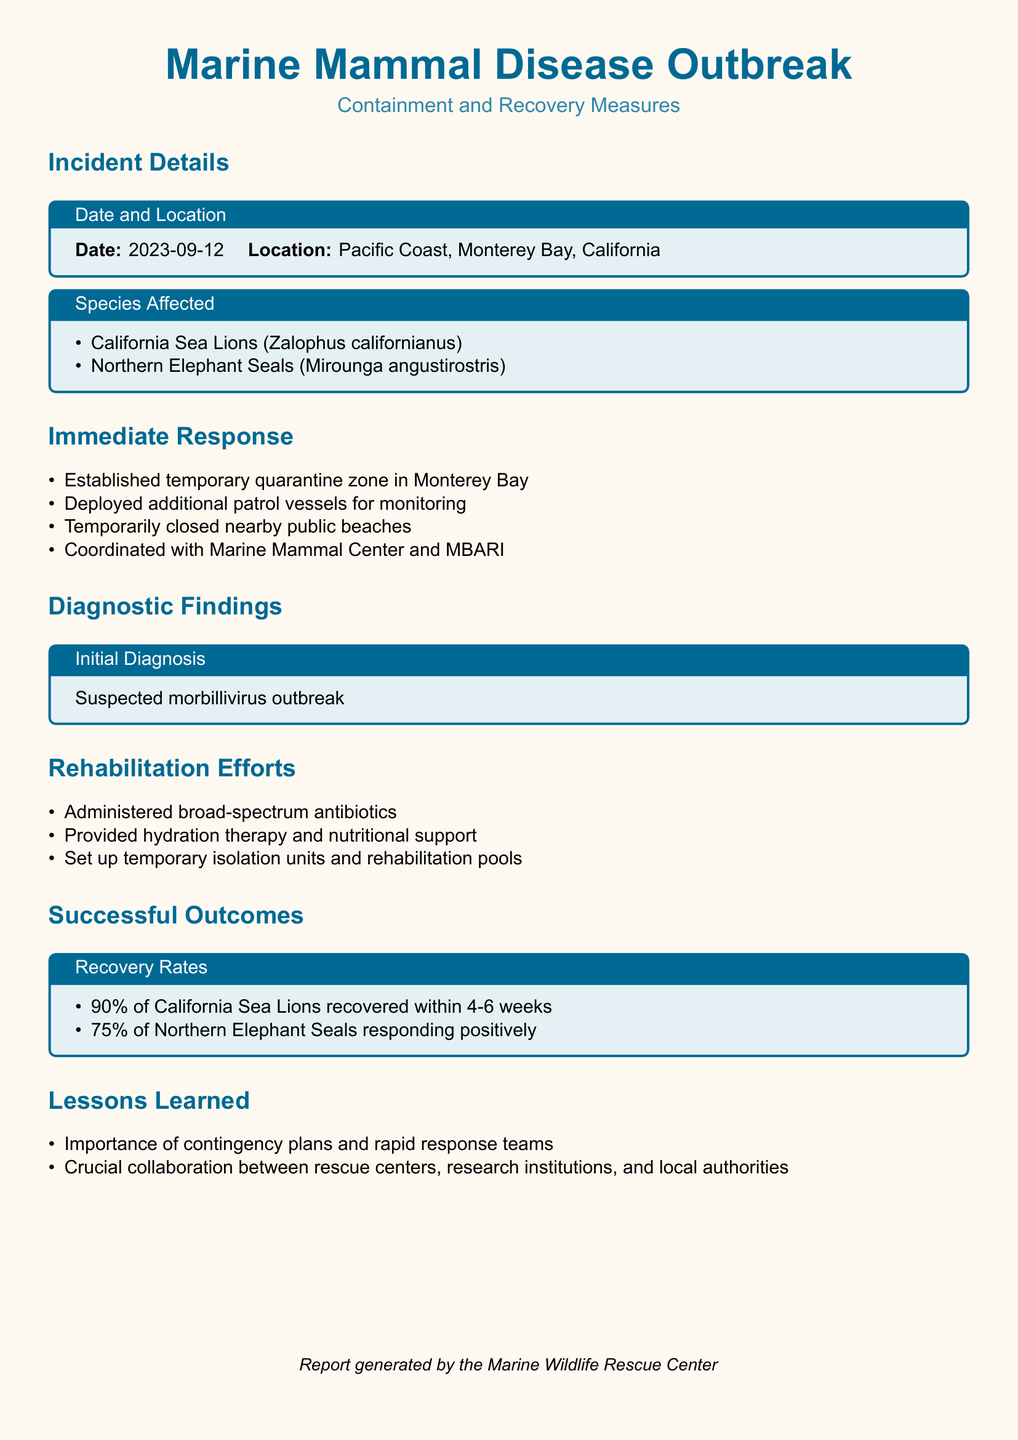What was the date of the incident? The date of the incident is provided in the document under "Incident Details."
Answer: 2023-09-12 Where did the outbreak occur? The location of the outbreak is stated in the document as "Incident Details."
Answer: Pacific Coast, Monterey Bay, California Which species were affected by the disease outbreak? The document lists affected species under "Species Affected."
Answer: California Sea Lions and Northern Elephant Seals What was the initial diagnosis for the outbreak? The initial diagnosis is specified in the "Diagnostic Findings" section of the document.
Answer: Suspected morbillivirus outbreak What was the recovery rate of California Sea Lions? The recovery rate is mentioned in the "Successful Outcomes" section.
Answer: 90% of California Sea Lions recovered What percentage of Northern Elephant Seals showed positive responses? The document provides this information in the "Successful Outcomes" section.
Answer: 75% What measures were taken to respond immediately to the outbreak? The immediate response measures are listed in the "Immediate Response" section.
Answer: Established temporary quarantine zone What is one lesson learned from this incident? Lessons learned are summarized towards the end of the document.
Answer: Importance of contingency plans Who coordinated efforts with the Marine Mammal Center? The document mentions collaboration with other entities under "Immediate Response."
Answer: MBARI 